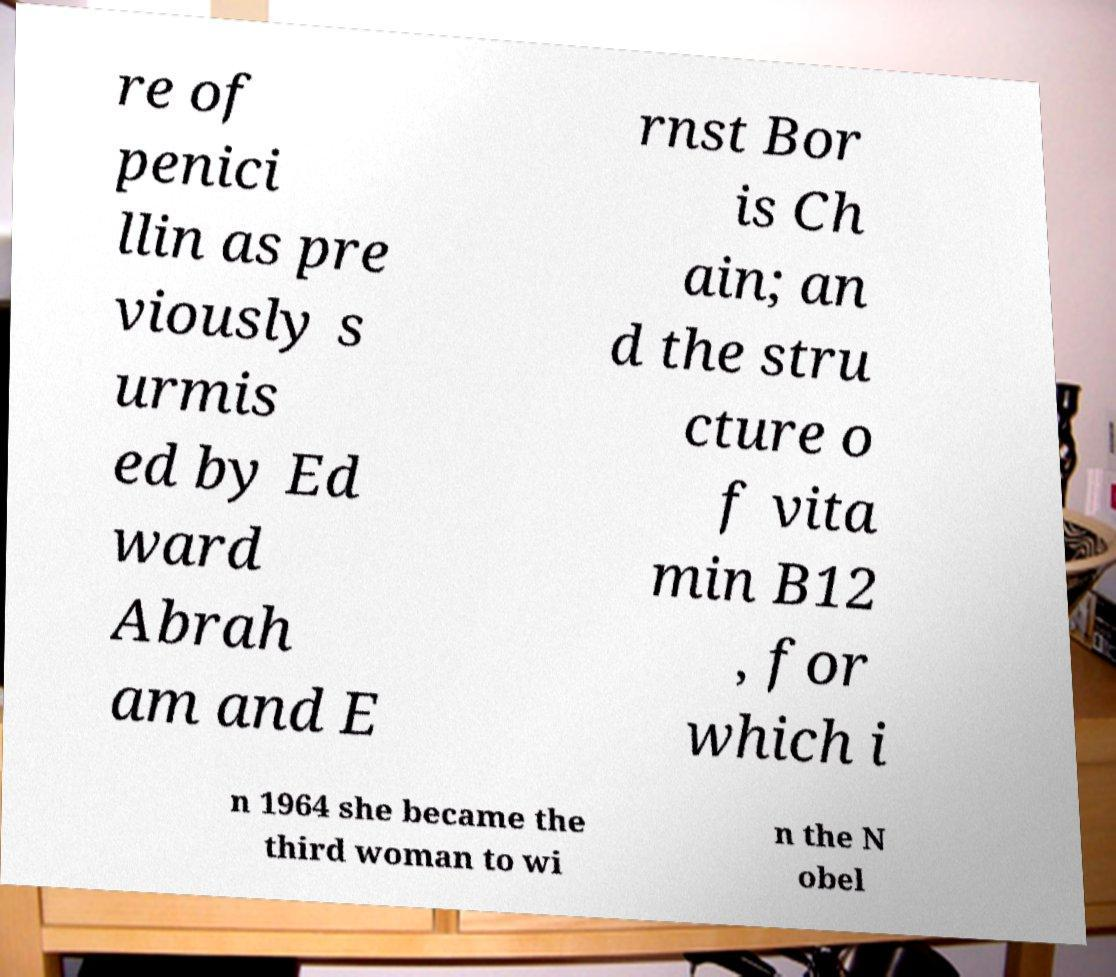Can you accurately transcribe the text from the provided image for me? re of penici llin as pre viously s urmis ed by Ed ward Abrah am and E rnst Bor is Ch ain; an d the stru cture o f vita min B12 , for which i n 1964 she became the third woman to wi n the N obel 